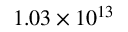<formula> <loc_0><loc_0><loc_500><loc_500>1 . 0 3 \times 1 0 ^ { 1 3 }</formula> 